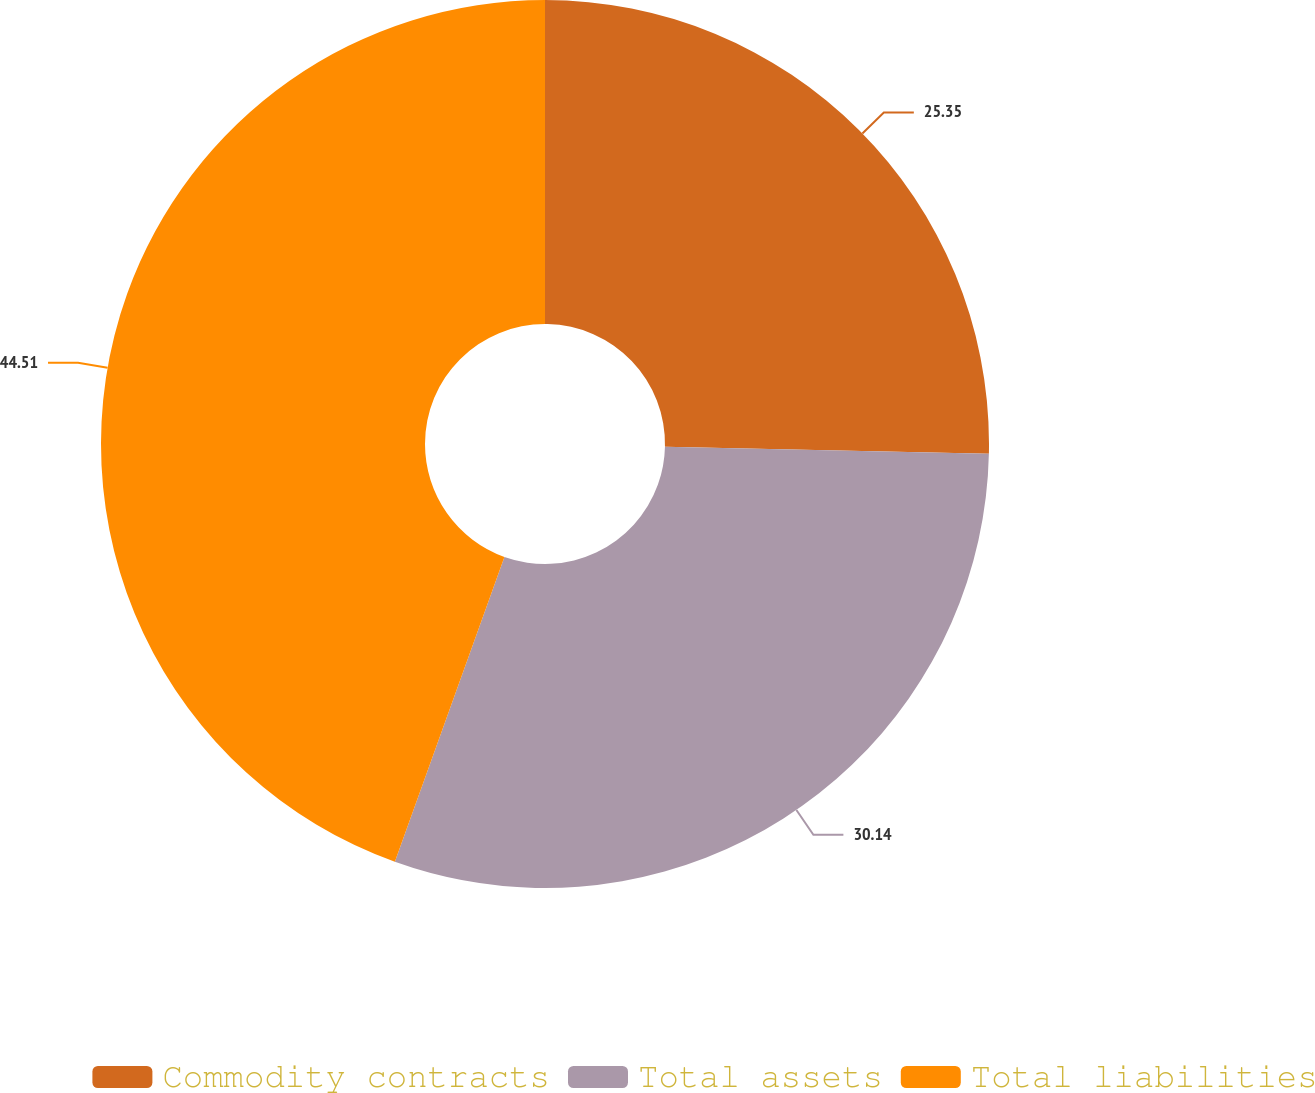Convert chart. <chart><loc_0><loc_0><loc_500><loc_500><pie_chart><fcel>Commodity contracts<fcel>Total assets<fcel>Total liabilities<nl><fcel>25.35%<fcel>30.14%<fcel>44.51%<nl></chart> 